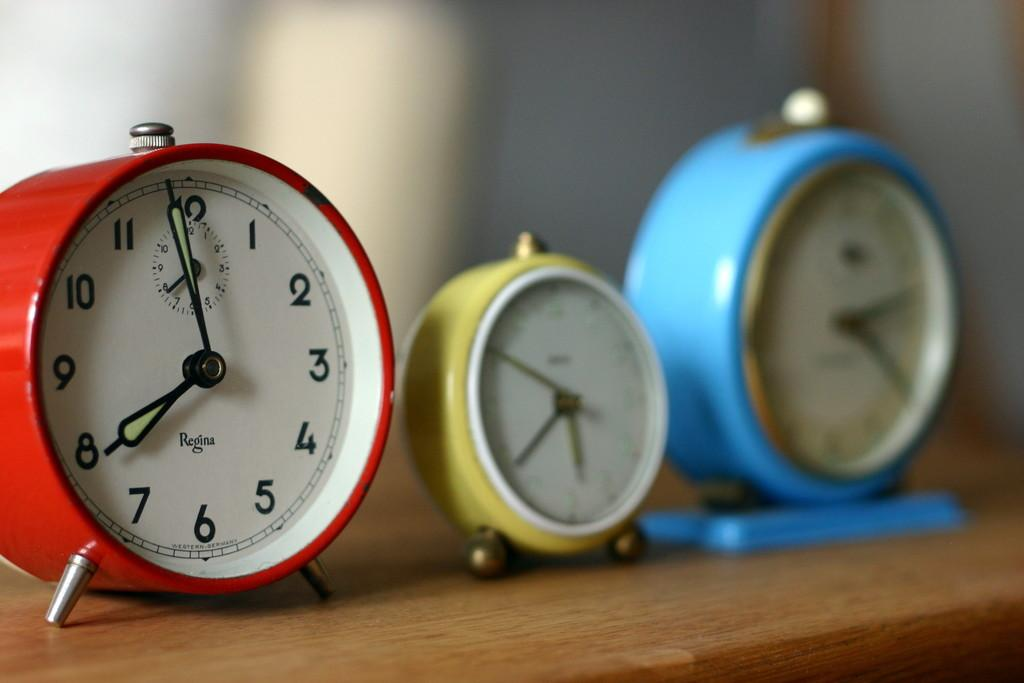<image>
Provide a brief description of the given image. Three vintage alarm clocks by the maker Regina sit on a table. 